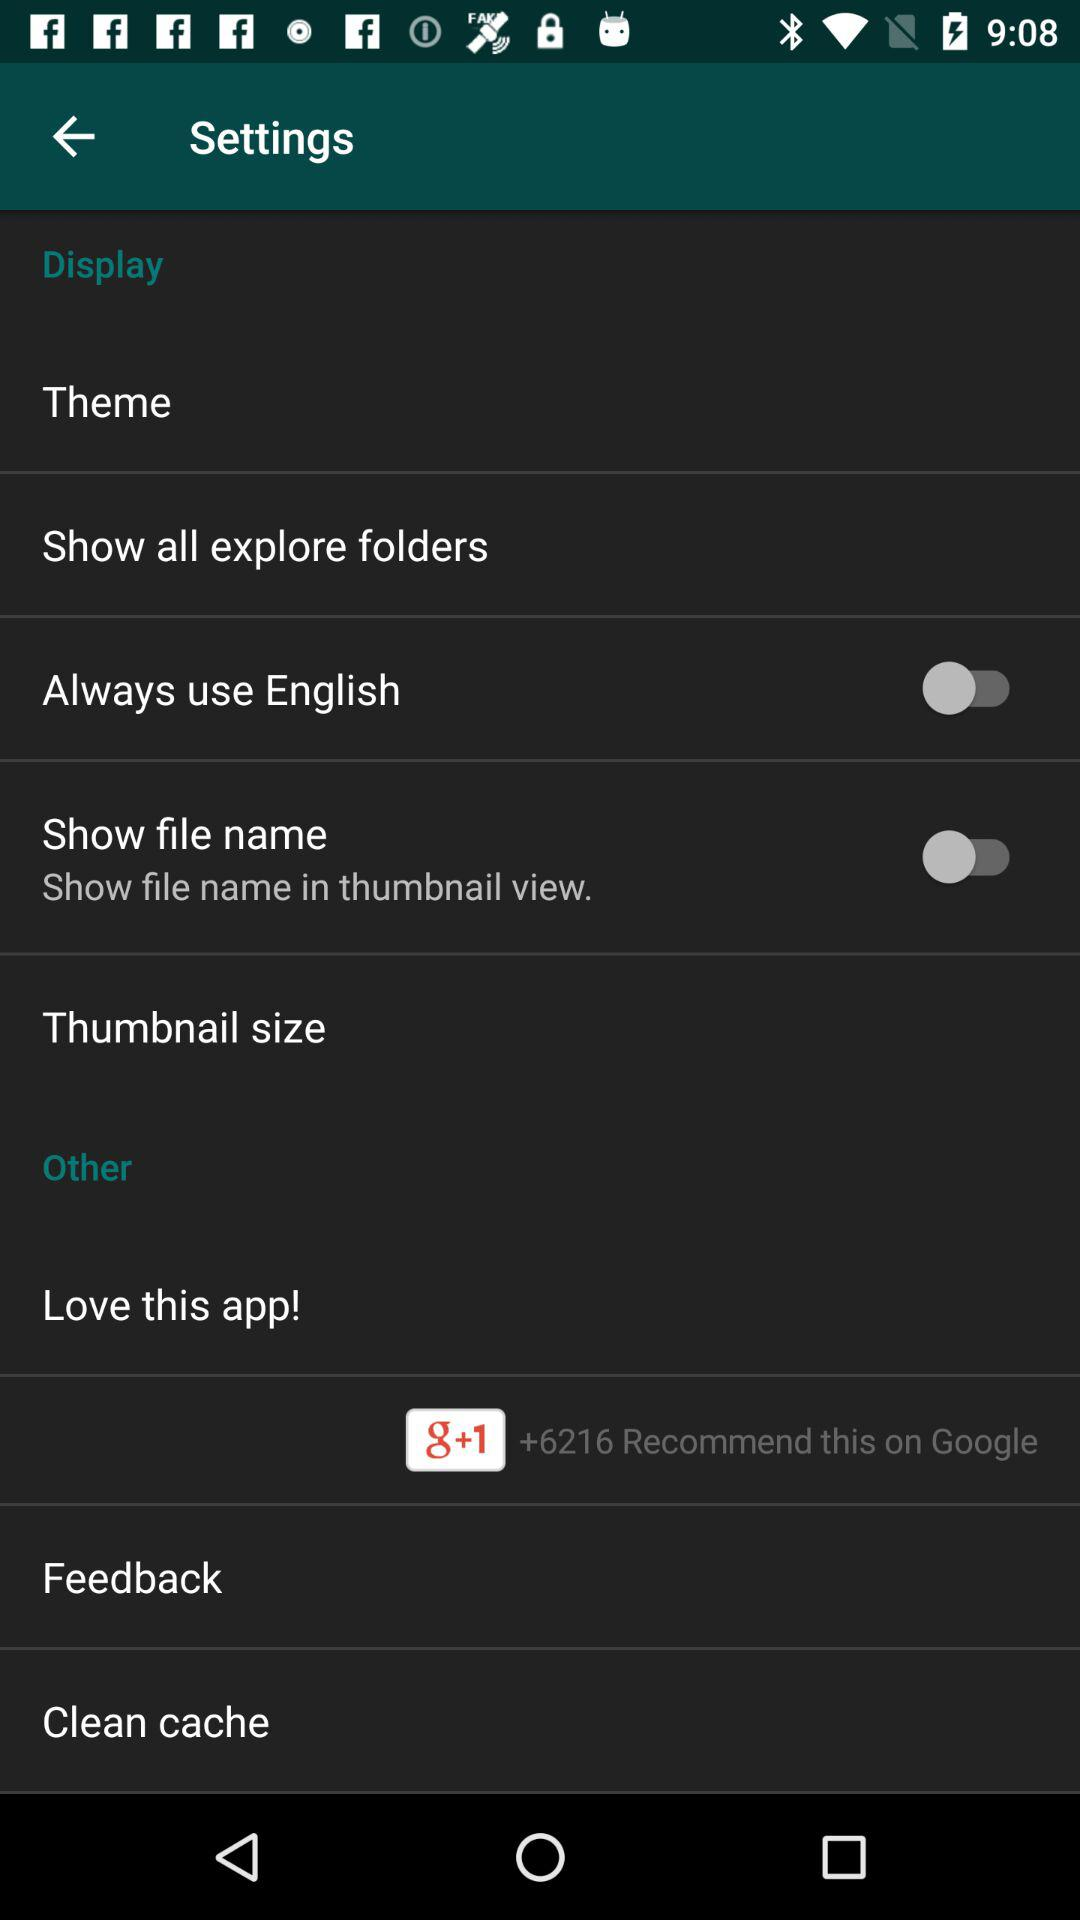What is the status of the "Show file name" setting? The status is "off". 